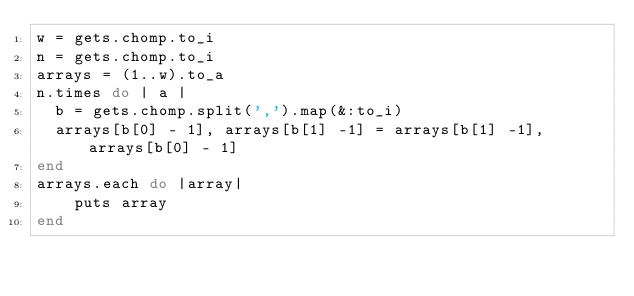<code> <loc_0><loc_0><loc_500><loc_500><_Ruby_>w = gets.chomp.to_i
n = gets.chomp.to_i
arrays = (1..w).to_a
n.times do | a |
  b = gets.chomp.split(',').map(&:to_i)
  arrays[b[0] - 1], arrays[b[1] -1] = arrays[b[1] -1], arrays[b[0] - 1]
end
arrays.each do |array|
    puts array
end
</code> 